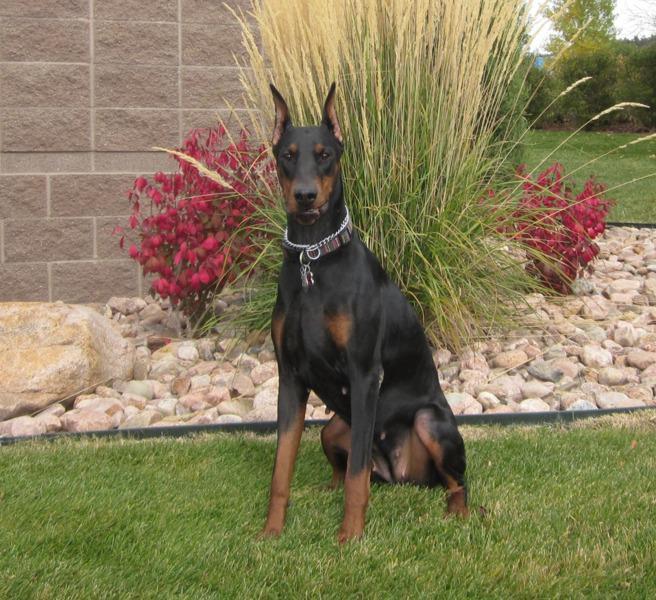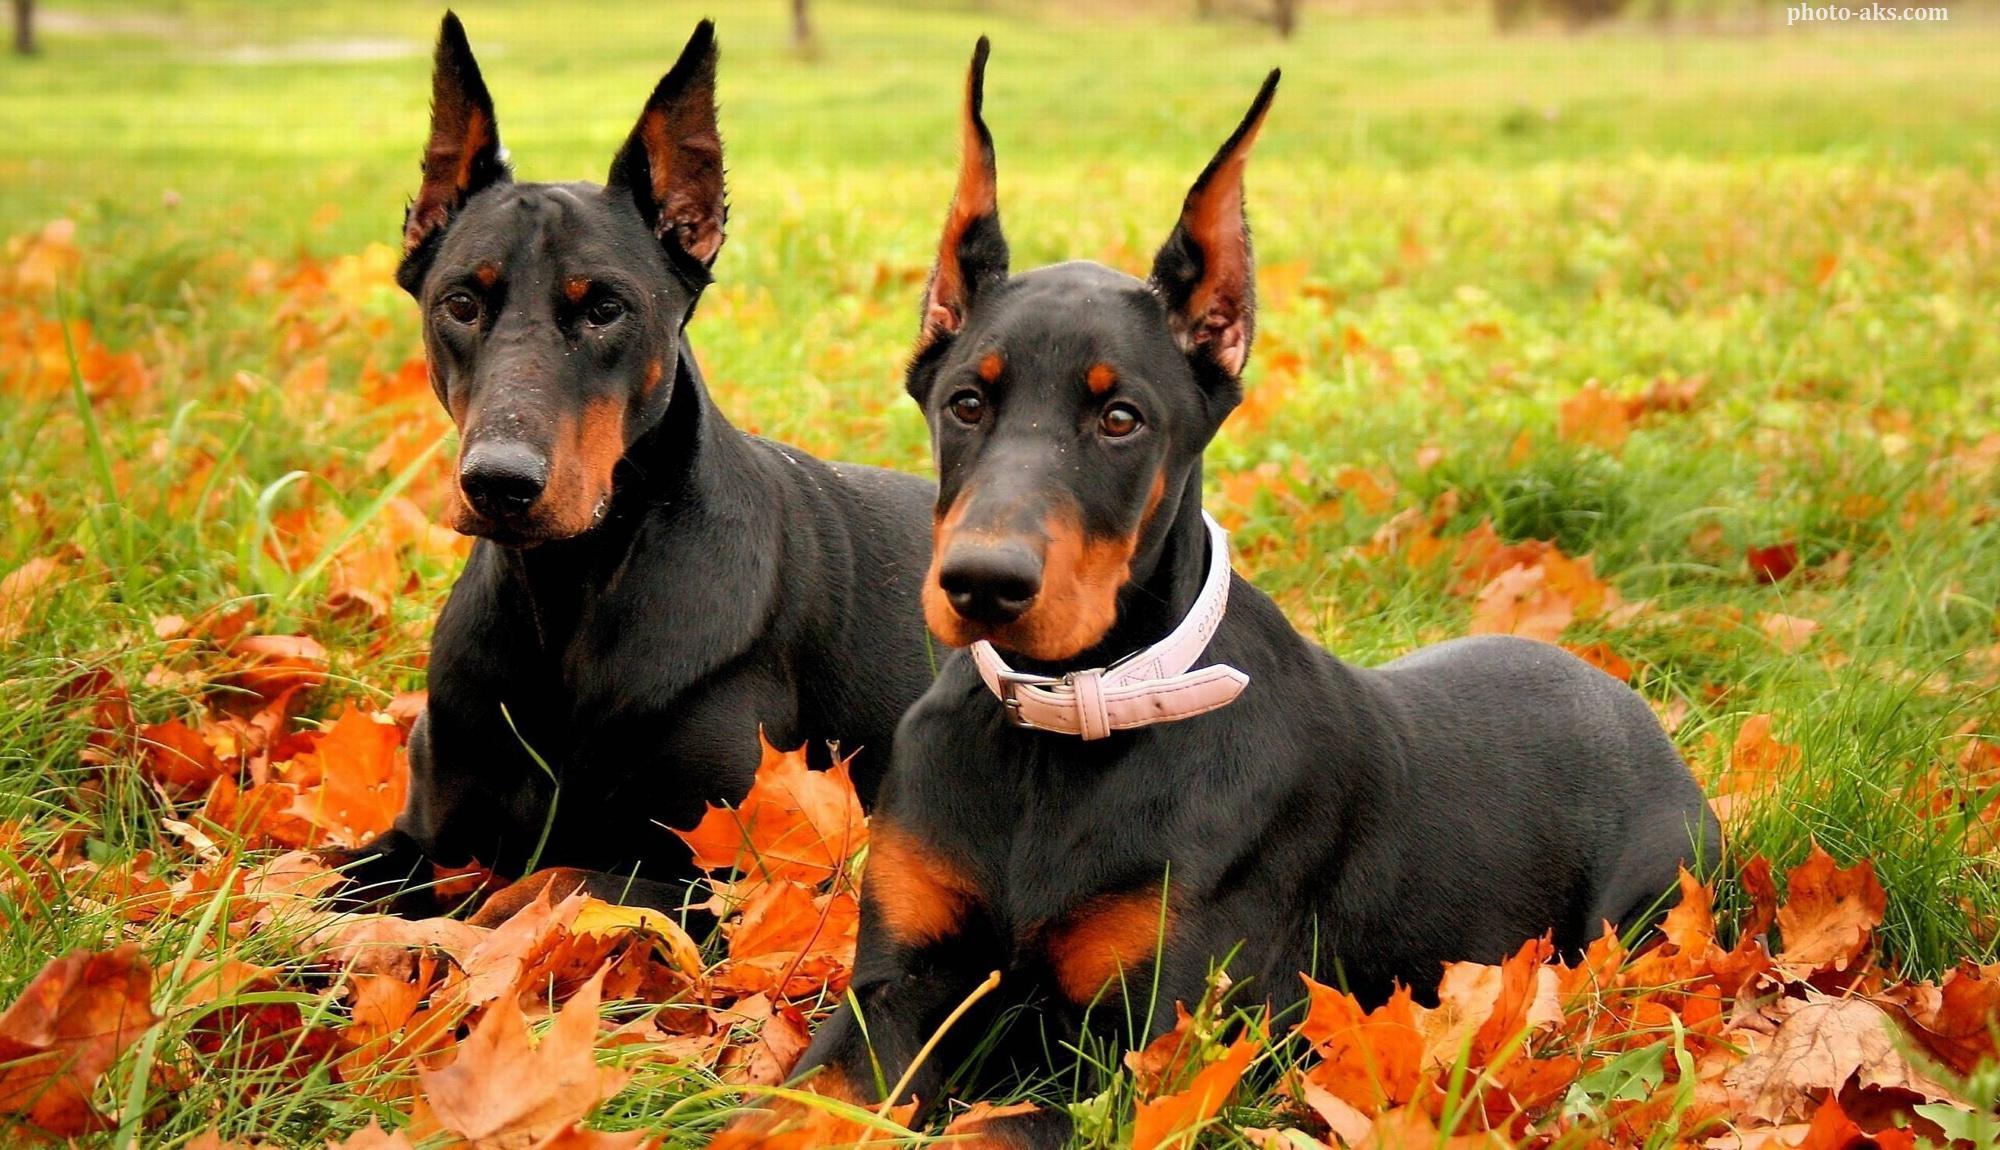The first image is the image on the left, the second image is the image on the right. Evaluate the accuracy of this statement regarding the images: "The combined images contain exactly two reclining dobermans with upright ears and faces angled forward so both eyes are visible.". Is it true? Answer yes or no. Yes. The first image is the image on the left, the second image is the image on the right. Evaluate the accuracy of this statement regarding the images: "There are at least three dogs in total.". Is it true? Answer yes or no. Yes. 